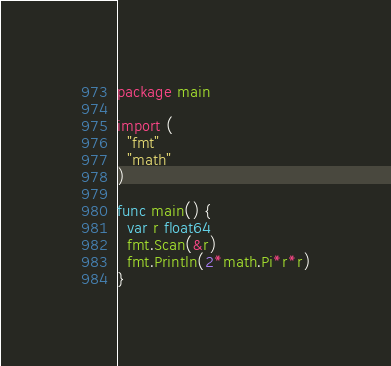Convert code to text. <code><loc_0><loc_0><loc_500><loc_500><_Go_>package main

import (
  "fmt"
  "math"
)

func main() {
  var r float64
  fmt.Scan(&r)
  fmt.Println(2*math.Pi*r*r)
}</code> 